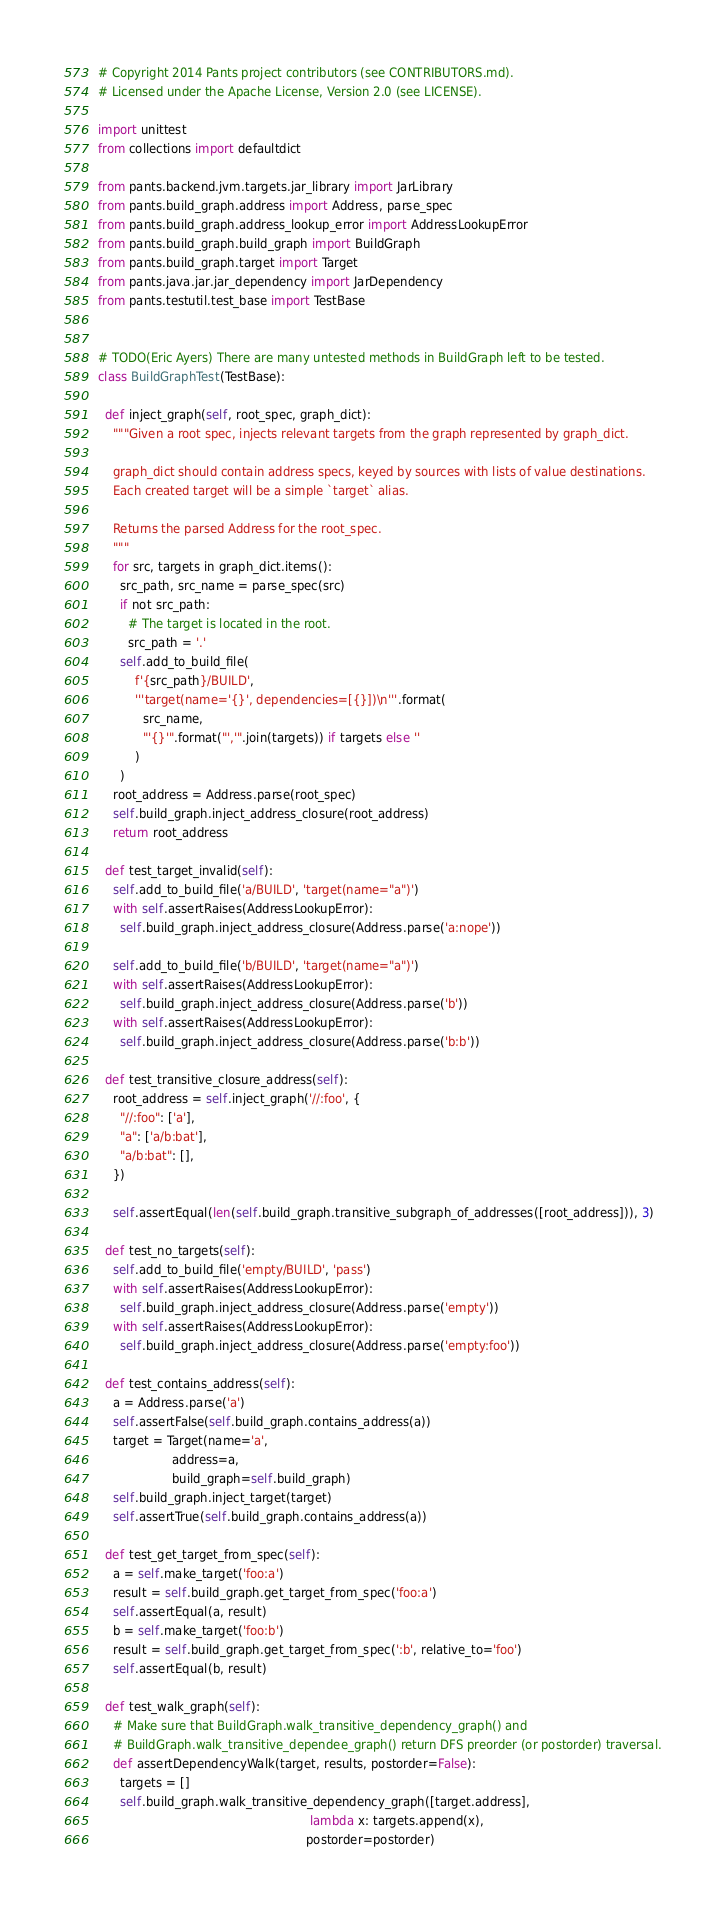<code> <loc_0><loc_0><loc_500><loc_500><_Python_># Copyright 2014 Pants project contributors (see CONTRIBUTORS.md).
# Licensed under the Apache License, Version 2.0 (see LICENSE).

import unittest
from collections import defaultdict

from pants.backend.jvm.targets.jar_library import JarLibrary
from pants.build_graph.address import Address, parse_spec
from pants.build_graph.address_lookup_error import AddressLookupError
from pants.build_graph.build_graph import BuildGraph
from pants.build_graph.target import Target
from pants.java.jar.jar_dependency import JarDependency
from pants.testutil.test_base import TestBase


# TODO(Eric Ayers) There are many untested methods in BuildGraph left to be tested.
class BuildGraphTest(TestBase):

  def inject_graph(self, root_spec, graph_dict):
    """Given a root spec, injects relevant targets from the graph represented by graph_dict.

    graph_dict should contain address specs, keyed by sources with lists of value destinations.
    Each created target will be a simple `target` alias.

    Returns the parsed Address for the root_spec.
    """
    for src, targets in graph_dict.items():
      src_path, src_name = parse_spec(src)
      if not src_path:
        # The target is located in the root.
        src_path = '.'
      self.add_to_build_file(
          f'{src_path}/BUILD',
          '''target(name='{}', dependencies=[{}])\n'''.format(
            src_name,
            "'{}'".format("','".join(targets)) if targets else ''
          )
      )
    root_address = Address.parse(root_spec)
    self.build_graph.inject_address_closure(root_address)
    return root_address

  def test_target_invalid(self):
    self.add_to_build_file('a/BUILD', 'target(name="a")')
    with self.assertRaises(AddressLookupError):
      self.build_graph.inject_address_closure(Address.parse('a:nope'))

    self.add_to_build_file('b/BUILD', 'target(name="a")')
    with self.assertRaises(AddressLookupError):
      self.build_graph.inject_address_closure(Address.parse('b'))
    with self.assertRaises(AddressLookupError):
      self.build_graph.inject_address_closure(Address.parse('b:b'))

  def test_transitive_closure_address(self):
    root_address = self.inject_graph('//:foo', {
      "//:foo": ['a'],
      "a": ['a/b:bat'],
      "a/b:bat": [],
    })

    self.assertEqual(len(self.build_graph.transitive_subgraph_of_addresses([root_address])), 3)

  def test_no_targets(self):
    self.add_to_build_file('empty/BUILD', 'pass')
    with self.assertRaises(AddressLookupError):
      self.build_graph.inject_address_closure(Address.parse('empty'))
    with self.assertRaises(AddressLookupError):
      self.build_graph.inject_address_closure(Address.parse('empty:foo'))

  def test_contains_address(self):
    a = Address.parse('a')
    self.assertFalse(self.build_graph.contains_address(a))
    target = Target(name='a',
                    address=a,
                    build_graph=self.build_graph)
    self.build_graph.inject_target(target)
    self.assertTrue(self.build_graph.contains_address(a))

  def test_get_target_from_spec(self):
    a = self.make_target('foo:a')
    result = self.build_graph.get_target_from_spec('foo:a')
    self.assertEqual(a, result)
    b = self.make_target('foo:b')
    result = self.build_graph.get_target_from_spec(':b', relative_to='foo')
    self.assertEqual(b, result)

  def test_walk_graph(self):
    # Make sure that BuildGraph.walk_transitive_dependency_graph() and
    # BuildGraph.walk_transitive_dependee_graph() return DFS preorder (or postorder) traversal.
    def assertDependencyWalk(target, results, postorder=False):
      targets = []
      self.build_graph.walk_transitive_dependency_graph([target.address],
                                                         lambda x: targets.append(x),
                                                        postorder=postorder)</code> 